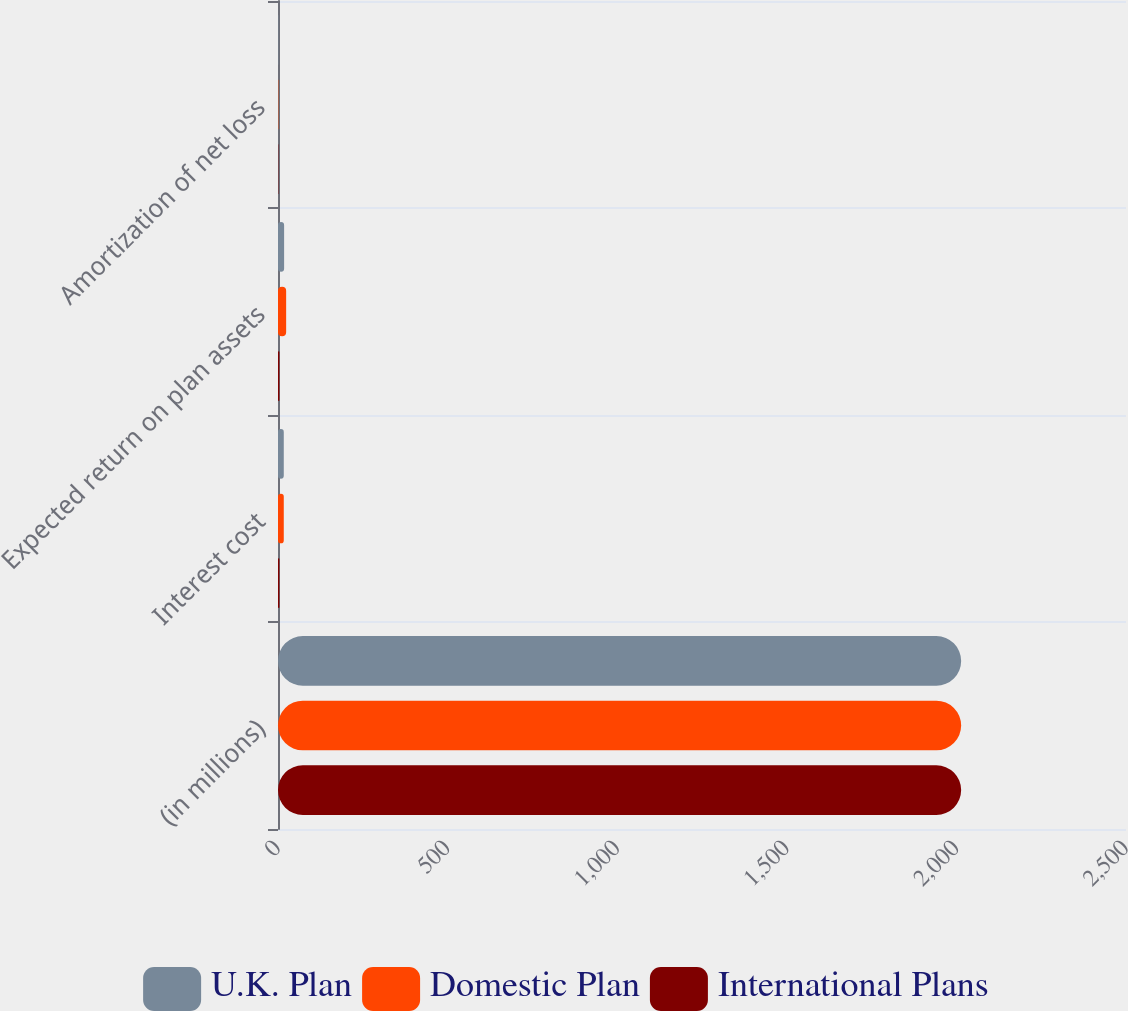Convert chart to OTSL. <chart><loc_0><loc_0><loc_500><loc_500><stacked_bar_chart><ecel><fcel>(in millions)<fcel>Interest cost<fcel>Expected return on plan assets<fcel>Amortization of net loss<nl><fcel>U.K. Plan<fcel>2014<fcel>17<fcel>18<fcel>1<nl><fcel>Domestic Plan<fcel>2014<fcel>17<fcel>24<fcel>1<nl><fcel>International Plans<fcel>2014<fcel>4<fcel>4<fcel>1<nl></chart> 